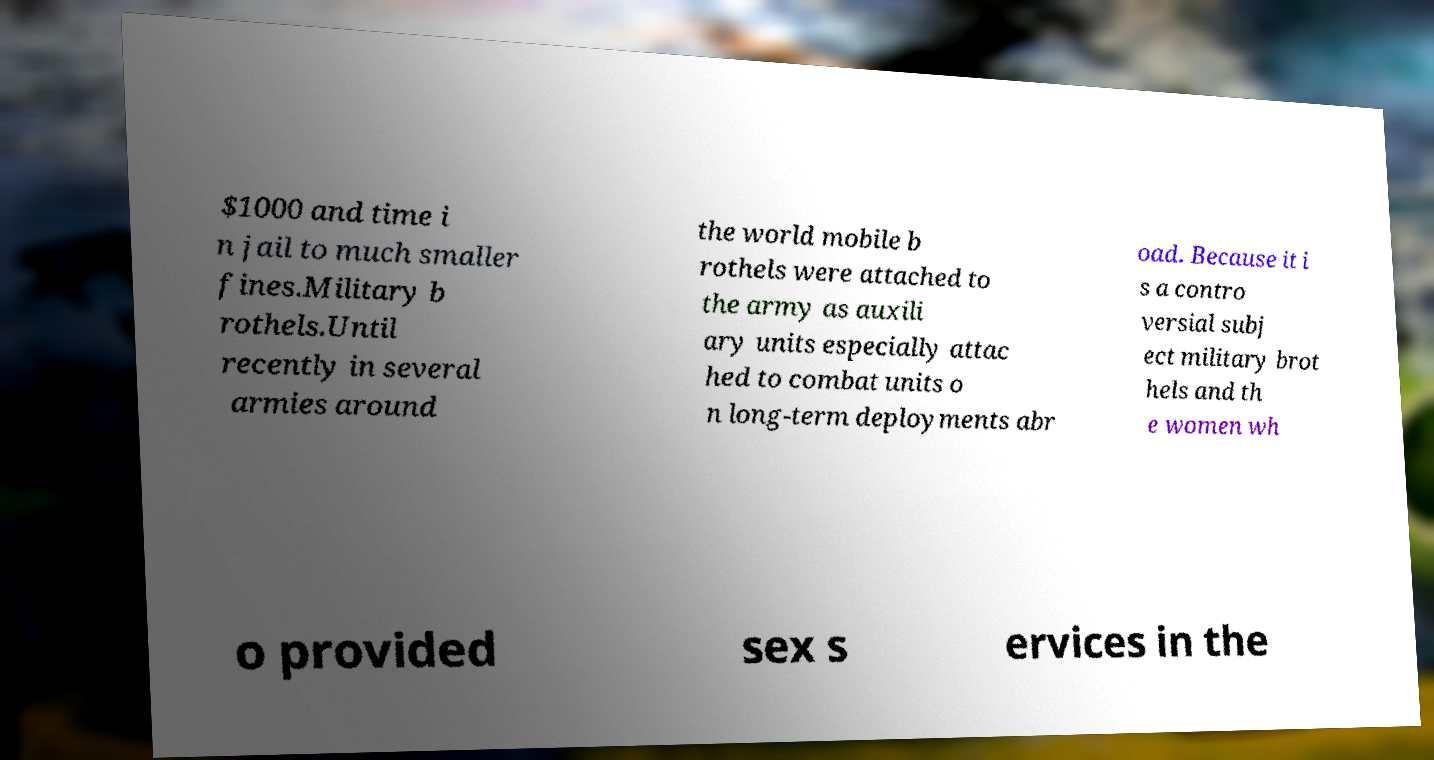There's text embedded in this image that I need extracted. Can you transcribe it verbatim? $1000 and time i n jail to much smaller fines.Military b rothels.Until recently in several armies around the world mobile b rothels were attached to the army as auxili ary units especially attac hed to combat units o n long-term deployments abr oad. Because it i s a contro versial subj ect military brot hels and th e women wh o provided sex s ervices in the 